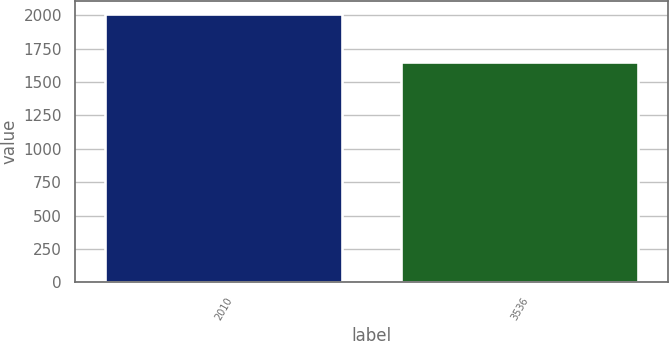Convert chart. <chart><loc_0><loc_0><loc_500><loc_500><bar_chart><fcel>2010<fcel>3536<nl><fcel>2008<fcel>1649<nl></chart> 